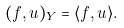Convert formula to latex. <formula><loc_0><loc_0><loc_500><loc_500>( f , u ) _ { Y } = \langle f , u \rangle .</formula> 